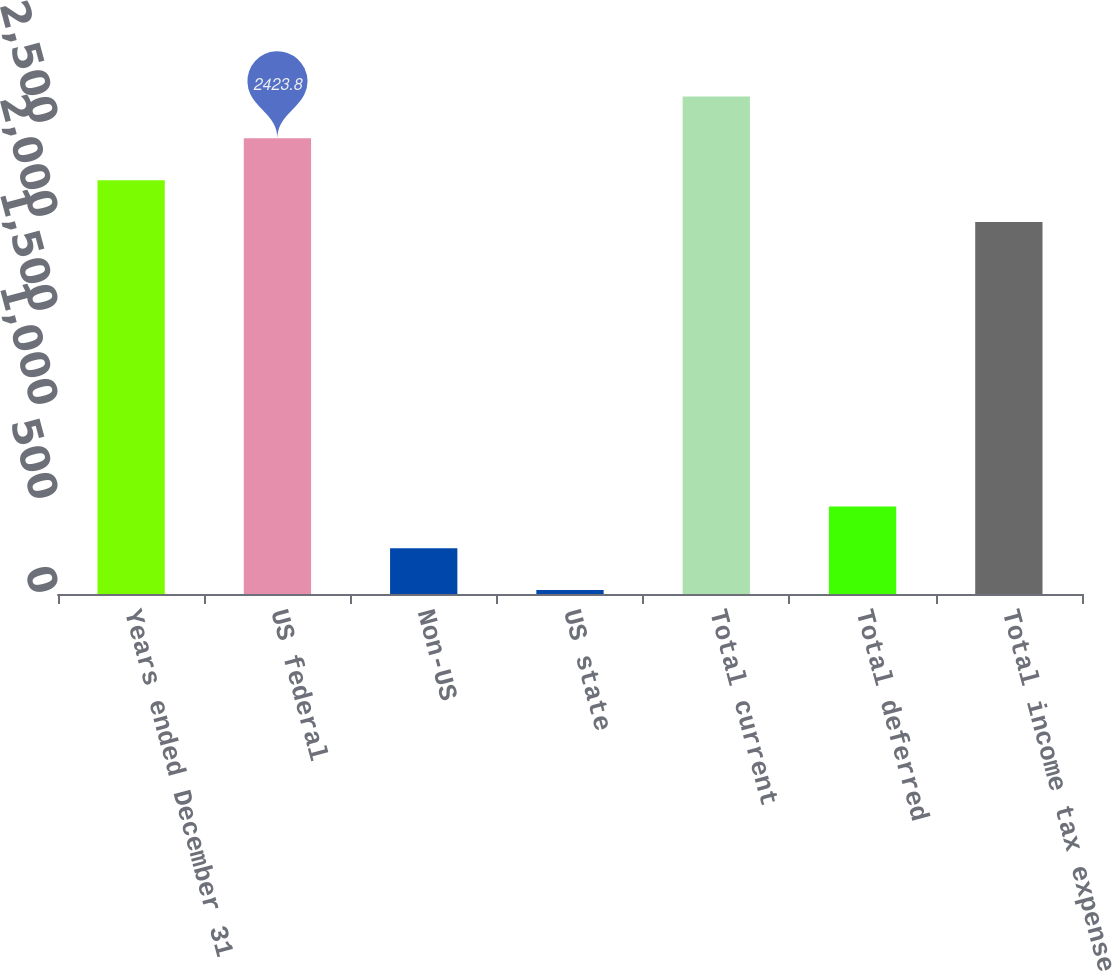<chart> <loc_0><loc_0><loc_500><loc_500><bar_chart><fcel>Years ended December 31<fcel>US federal<fcel>Non-US<fcel>US state<fcel>Total current<fcel>Total deferred<fcel>Total income tax expense<nl><fcel>2201.4<fcel>2423.8<fcel>243.4<fcel>21<fcel>2646.2<fcel>465.8<fcel>1979<nl></chart> 